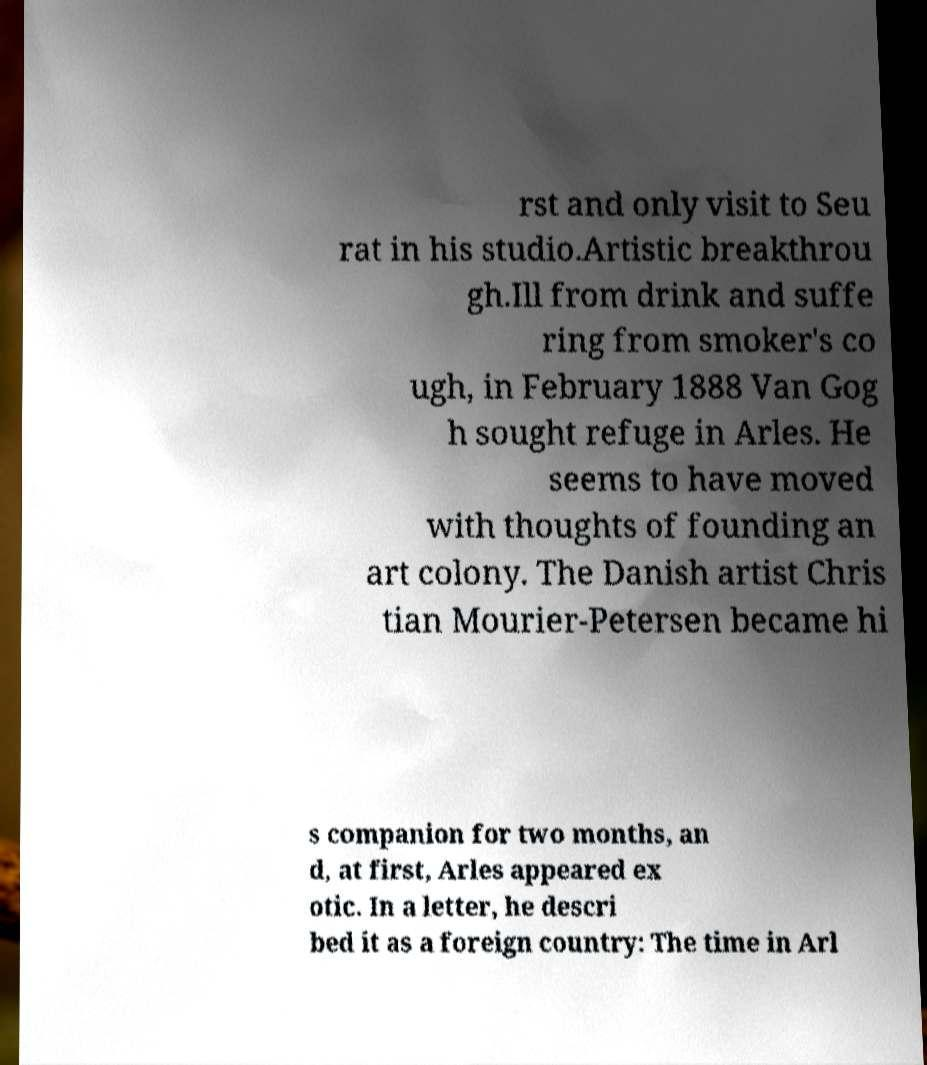For documentation purposes, I need the text within this image transcribed. Could you provide that? rst and only visit to Seu rat in his studio.Artistic breakthrou gh.Ill from drink and suffe ring from smoker's co ugh, in February 1888 Van Gog h sought refuge in Arles. He seems to have moved with thoughts of founding an art colony. The Danish artist Chris tian Mourier-Petersen became hi s companion for two months, an d, at first, Arles appeared ex otic. In a letter, he descri bed it as a foreign country: The time in Arl 